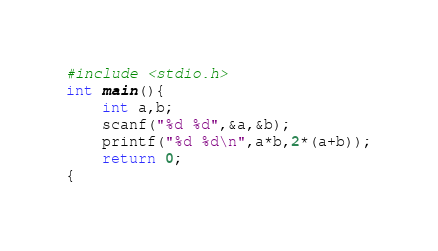<code> <loc_0><loc_0><loc_500><loc_500><_C_>#include <stdio.h>
int main(){
    int a,b;
    scanf("%d %d",&a,&b);
    printf("%d %d\n",a*b,2*(a+b));
    return 0;
{    
</code> 